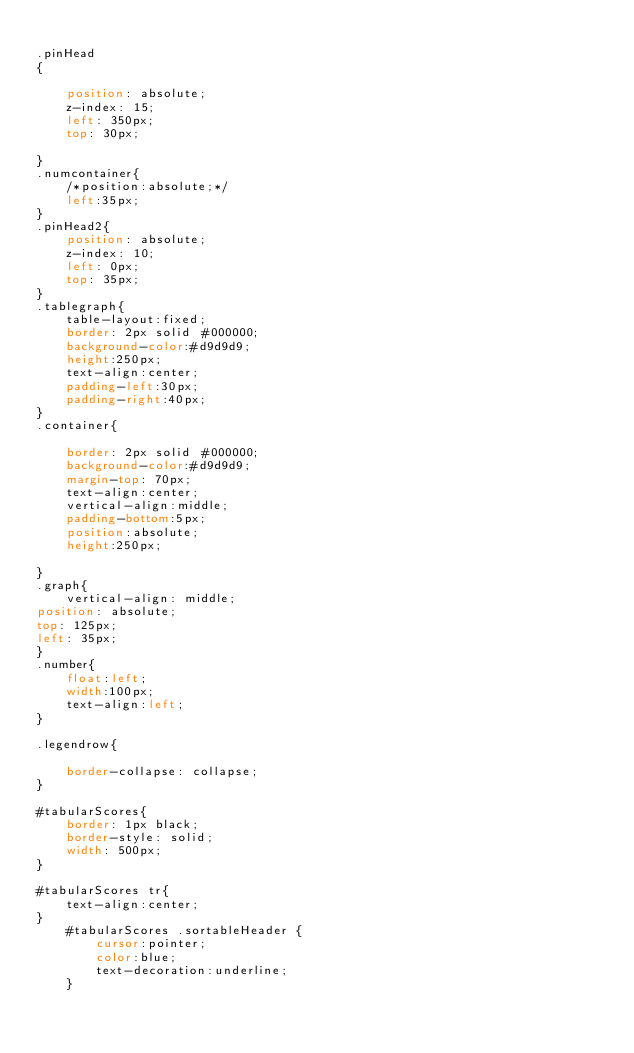Convert code to text. <code><loc_0><loc_0><loc_500><loc_500><_CSS_>
.pinHead
{

	position: absolute;
	z-index: 15;
	left: 350px;
	top: 30px;

}
.numcontainer{
	/*position:absolute;*/
	left:35px;
}
.pinHead2{
	position: absolute;
	z-index: 10;
	left: 0px;
	top: 35px;
}
.tablegraph{
	table-layout:fixed;
	border: 2px solid #000000;
	background-color:#d9d9d9;
	height:250px;
	text-align:center;
	padding-left:30px;
	padding-right:40px;
}
.container{
	
	border: 2px solid #000000;
	background-color:#d9d9d9;
	margin-top: 70px;
	text-align:center;
	vertical-align:middle;
	padding-bottom:5px;
	position:absolute;
	height:250px;
	
}
.graph{
	vertical-align: middle;
position: absolute;
top: 125px;
left: 35px;
}
.number{
	float:left;
	width:100px;
	text-align:left;
}

.legendrow{
	
	border-collapse: collapse;
}

#tabularScores{
    border: 1px black;
    border-style: solid;
    width: 500px;
}

#tabularScores tr{
    text-align:center;
}
    #tabularScores .sortableHeader {
        cursor:pointer;
        color:blue;
        text-decoration:underline;
    }</code> 